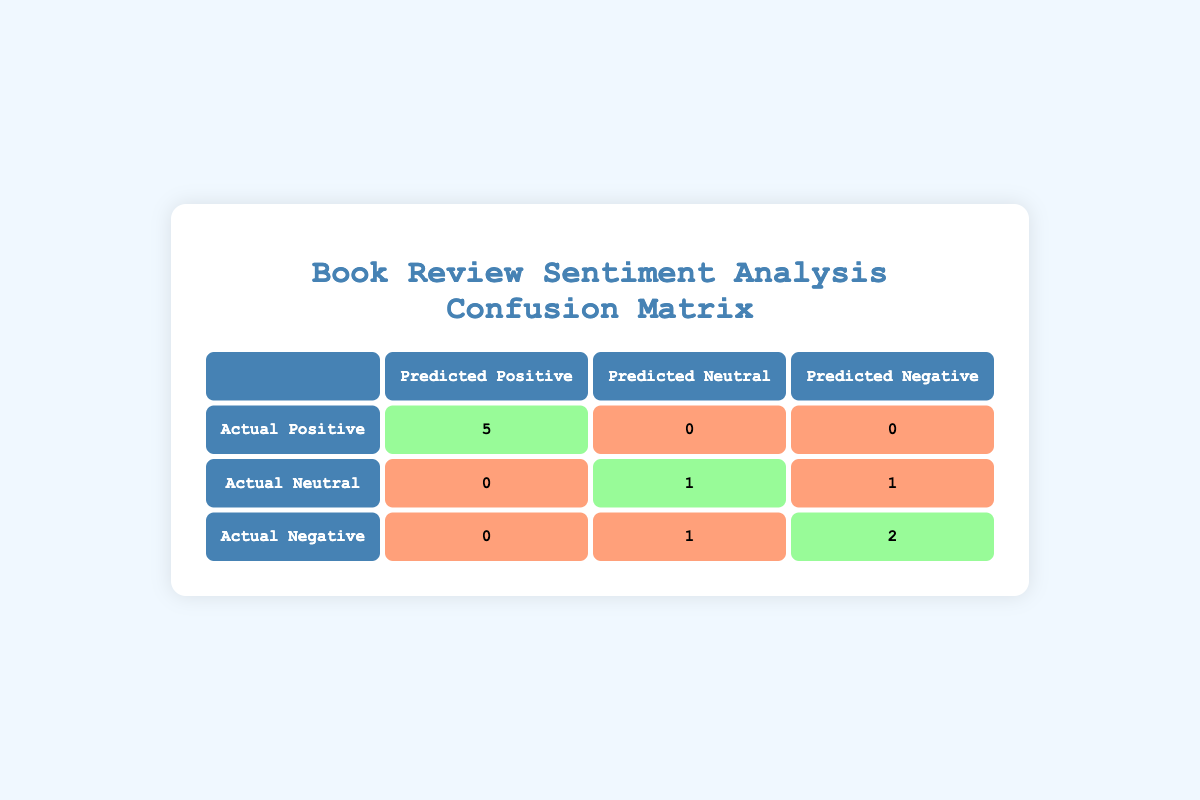What is the number of reviews that were correctly predicted as positive? The table shows that 5 reviews with actual positive ratings were correctly predicted as positive (in the "Actual Positive" row, "Predicted Positive" column).
Answer: 5 How many reviews were predicted as neutral? In the table, there is 1 review that was predicted as neutral (in the "Actual Neutral" row, "Predicted Neutral" column).
Answer: 1 What is the total number of reviews analyzed? To find the total, we sum the values in all cells of the table: 5 (TP) + 0 (FP) + 0 (FN) + 0 (FP) + 1 (TN) + 1 (FN) + 0 (FP) + 1 (FN) + 2 (TN) = 10.
Answer: 10 Were there any reviews incorrectly predicted as positive? Yes, according to the table, there were 0 reviews that were incorrectly predicted as positive (in the "Actual Neutral" and "Actual Negative" rows, there are no values in the "Predicted Positive" column).
Answer: No What percentage of actual positive reviews were correctly classified? There were 5 actual positive reviews, and all were correctly classified. The percentage is calculated as (5 correct predictions / 5 actual positives) * 100 = 100%.
Answer: 100% What is the total number of reviews that were predicted as negative? Looking at the table, there are 0 reviews predicted as negative among actual positives, 1 among actual neutral, and 2 among actual negatives, totaling 3 predicted negative reviews.
Answer: 3 How many reviews received a neutral sentiment prediction among actual negative reviews? The table indicates that 1 review was predicted as neutral, which is in the row for actual negative ratings, specifically in the "Predicted Neutral" column.
Answer: 1 How many reviews had negative actual ratings and were correctly predicted as negative? From the table, it shows that 2 reviews with actual negative ratings were correctly predicted as negative (in the "Actual Negative" row, "Predicted Negative" column).
Answer: 2 What is the difference between the number of actual neutral reviews and the number of reviews predicted as neutral? There is 1 actual neutral review and 1 predicted neutral review, so the difference is 1 (actual) - 1 (predicted) = 0.
Answer: 0 